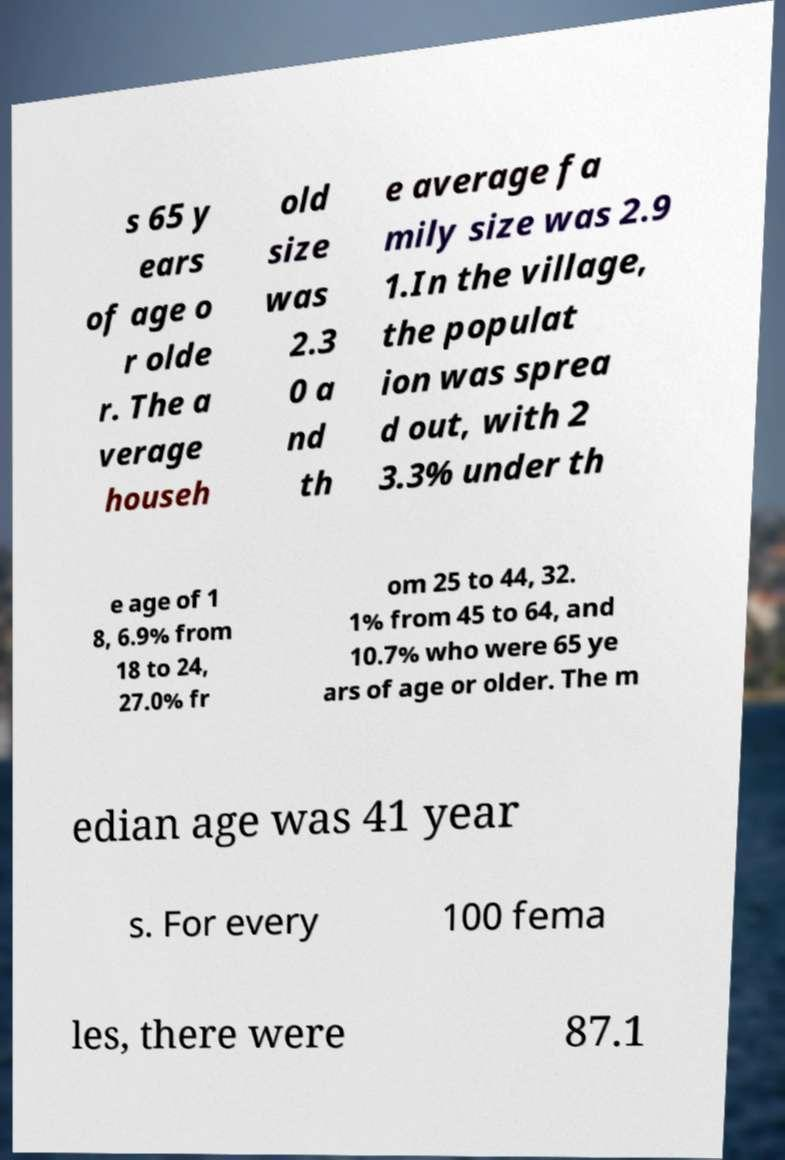Can you accurately transcribe the text from the provided image for me? s 65 y ears of age o r olde r. The a verage househ old size was 2.3 0 a nd th e average fa mily size was 2.9 1.In the village, the populat ion was sprea d out, with 2 3.3% under th e age of 1 8, 6.9% from 18 to 24, 27.0% fr om 25 to 44, 32. 1% from 45 to 64, and 10.7% who were 65 ye ars of age or older. The m edian age was 41 year s. For every 100 fema les, there were 87.1 